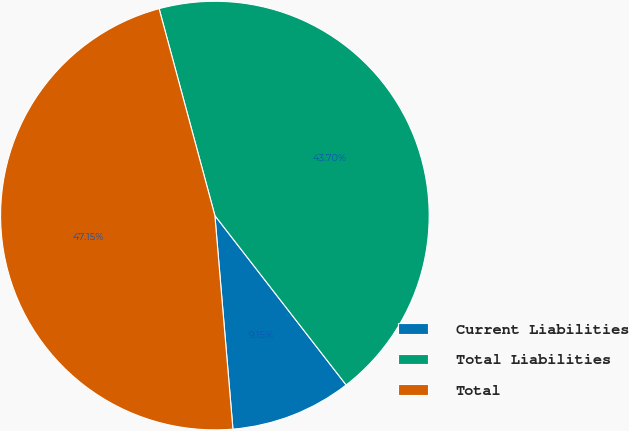<chart> <loc_0><loc_0><loc_500><loc_500><pie_chart><fcel>Current Liabilities<fcel>Total Liabilities<fcel>Total<nl><fcel>9.15%<fcel>43.7%<fcel>47.15%<nl></chart> 